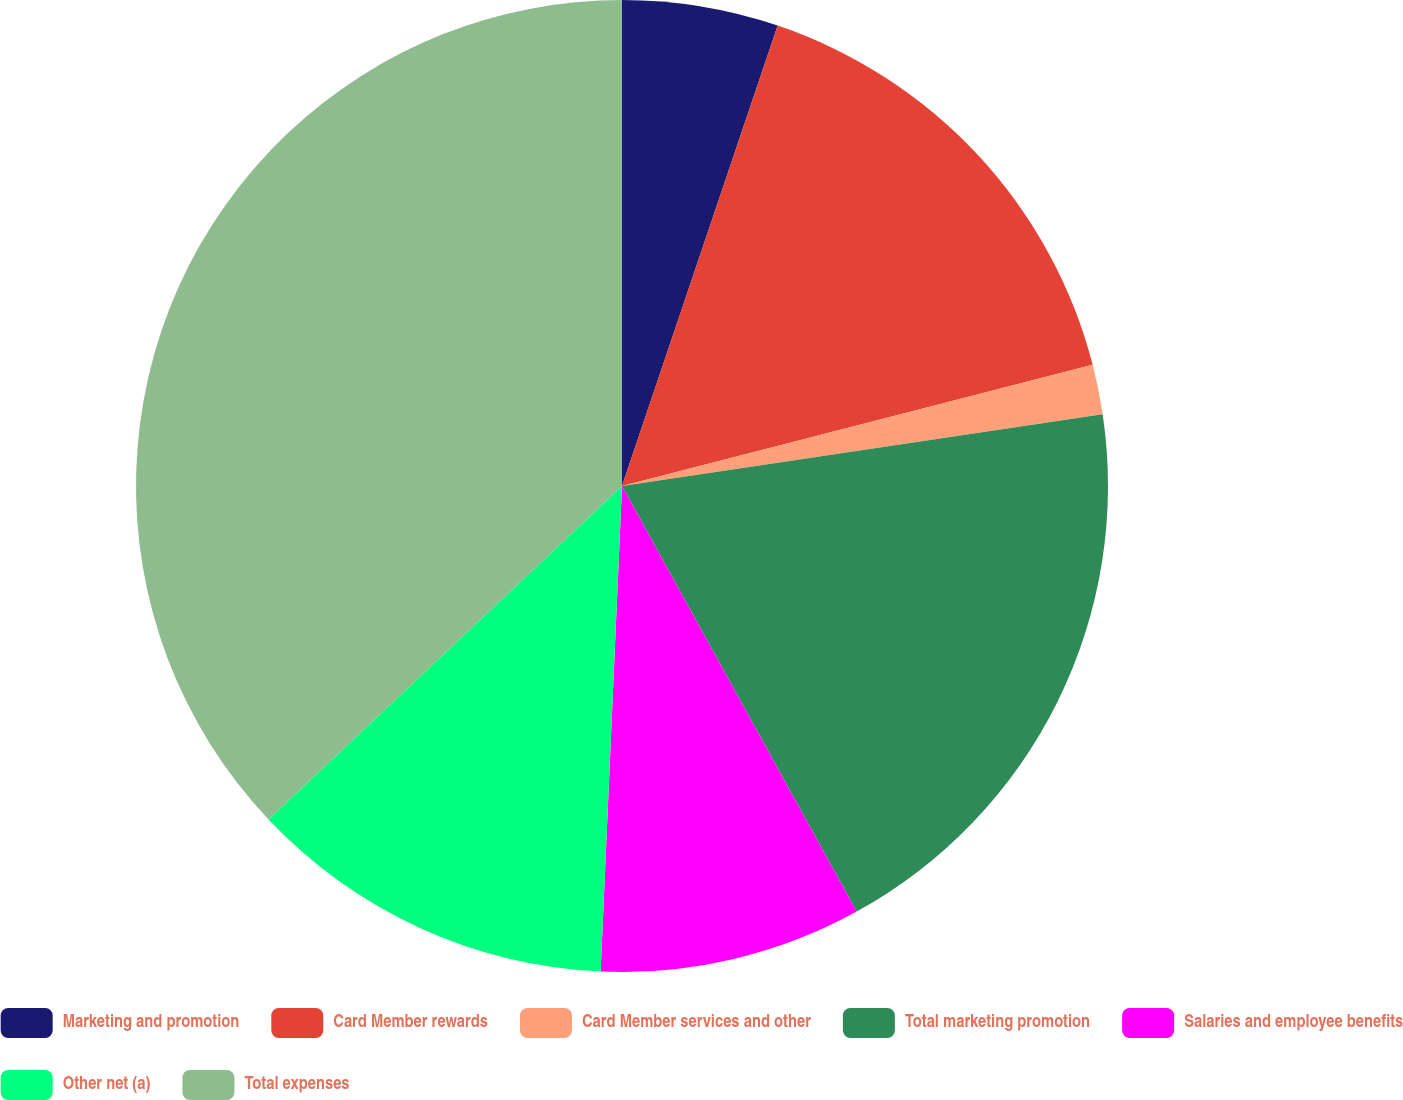Convert chart. <chart><loc_0><loc_0><loc_500><loc_500><pie_chart><fcel>Marketing and promotion<fcel>Card Member rewards<fcel>Card Member services and other<fcel>Total marketing promotion<fcel>Salaries and employee benefits<fcel>Other net (a)<fcel>Total expenses<nl><fcel>5.19%<fcel>15.8%<fcel>1.65%<fcel>19.34%<fcel>8.72%<fcel>12.26%<fcel>37.04%<nl></chart> 